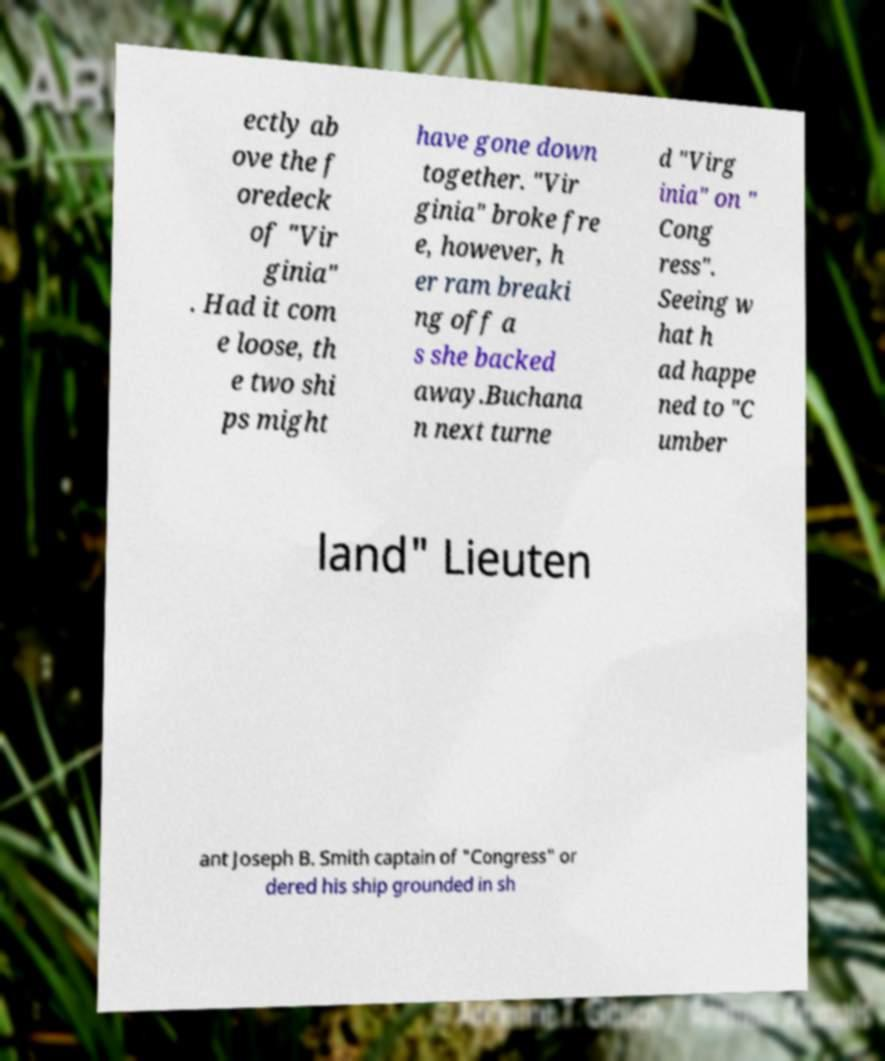There's text embedded in this image that I need extracted. Can you transcribe it verbatim? ectly ab ove the f oredeck of "Vir ginia" . Had it com e loose, th e two shi ps might have gone down together. "Vir ginia" broke fre e, however, h er ram breaki ng off a s she backed away.Buchana n next turne d "Virg inia" on " Cong ress". Seeing w hat h ad happe ned to "C umber land" Lieuten ant Joseph B. Smith captain of "Congress" or dered his ship grounded in sh 